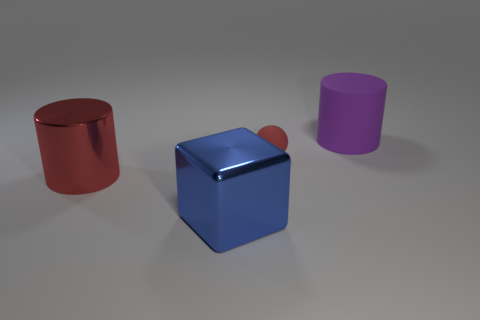There is a cylinder that is on the left side of the thing in front of the large cylinder left of the tiny red object; what is it made of? The cylinder on the left side, in front of the large cylinder and to the left of the small red sphere, appears to be a computer-generated object with a shiny, metal-like surface. However, without physical examination or additional information, it's not possible to determine the actual material in a real-world setting. Based on the image alone, the realistic texture suggests it is designed to simulate a metal material. 